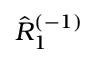Convert formula to latex. <formula><loc_0><loc_0><loc_500><loc_500>\hat { R } _ { 1 } ^ { ( - 1 ) }</formula> 